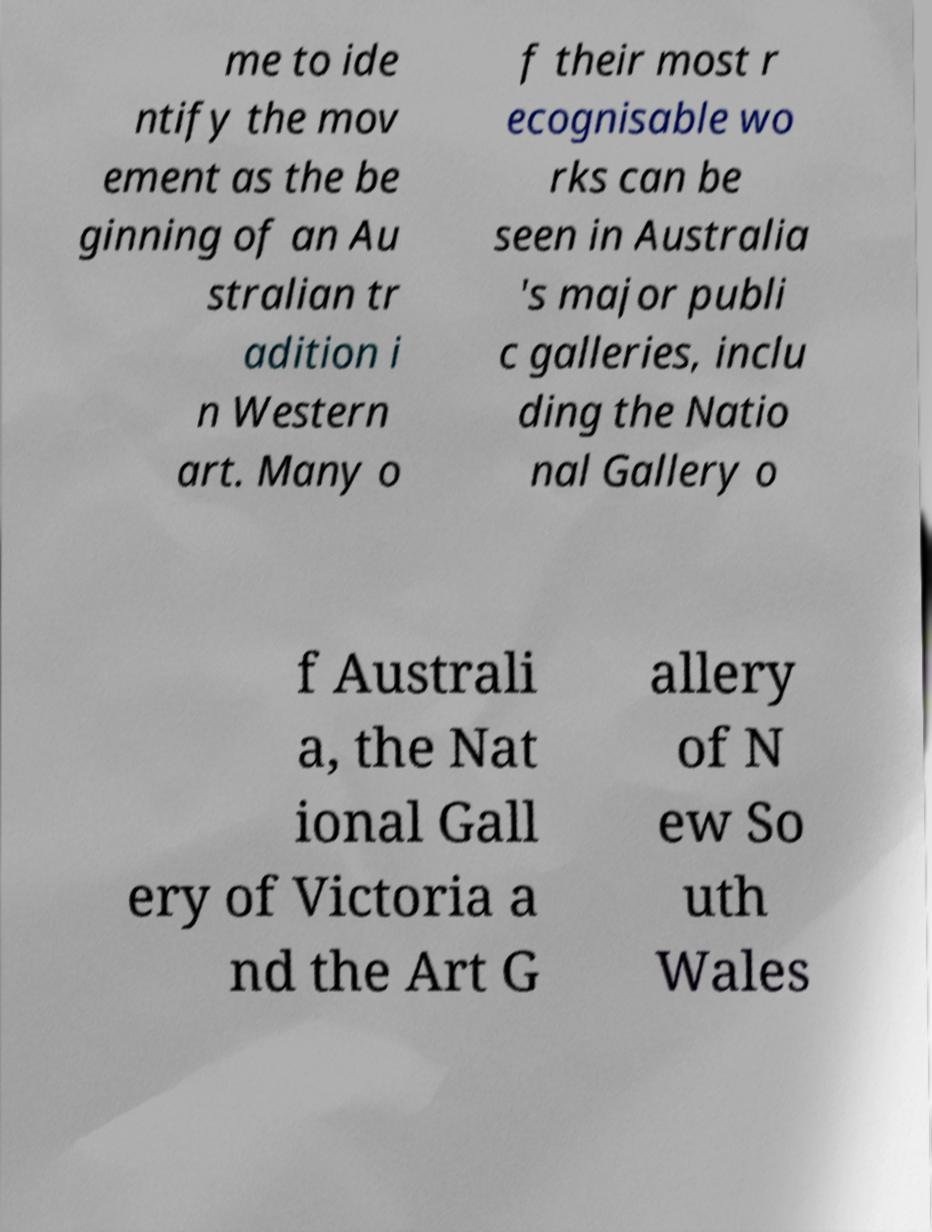Could you assist in decoding the text presented in this image and type it out clearly? me to ide ntify the mov ement as the be ginning of an Au stralian tr adition i n Western art. Many o f their most r ecognisable wo rks can be seen in Australia 's major publi c galleries, inclu ding the Natio nal Gallery o f Australi a, the Nat ional Gall ery of Victoria a nd the Art G allery of N ew So uth Wales 